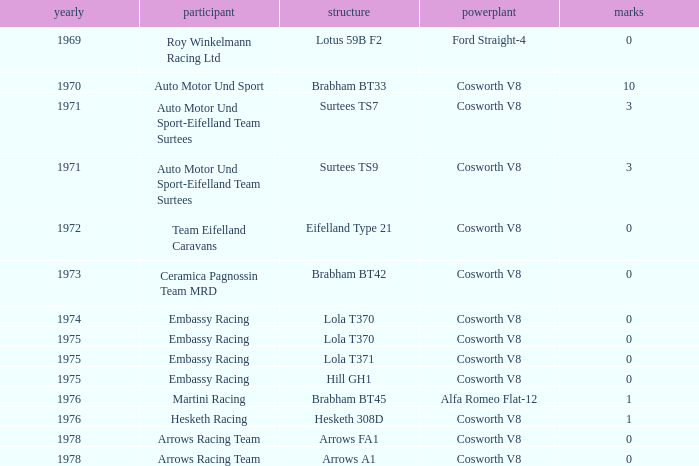What was the total amount of points in 1978 with a Chassis of arrows fa1? 0.0. 